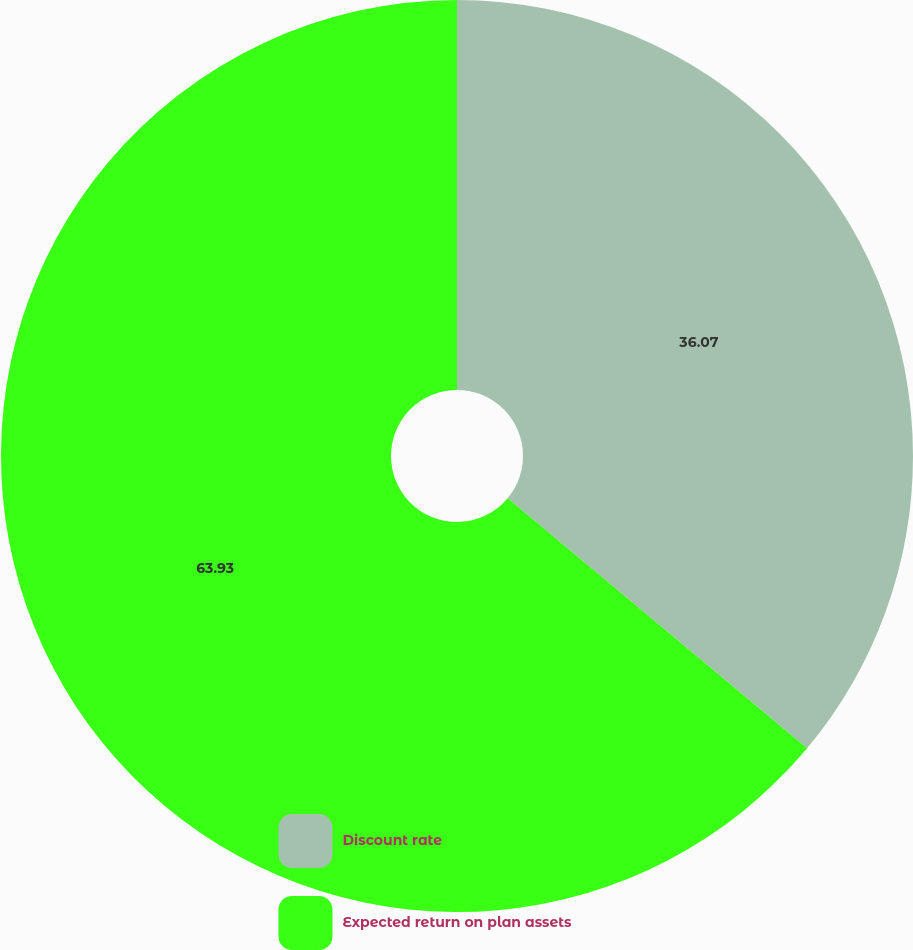<chart> <loc_0><loc_0><loc_500><loc_500><pie_chart><fcel>Discount rate<fcel>Expected return on plan assets<nl><fcel>36.07%<fcel>63.93%<nl></chart> 